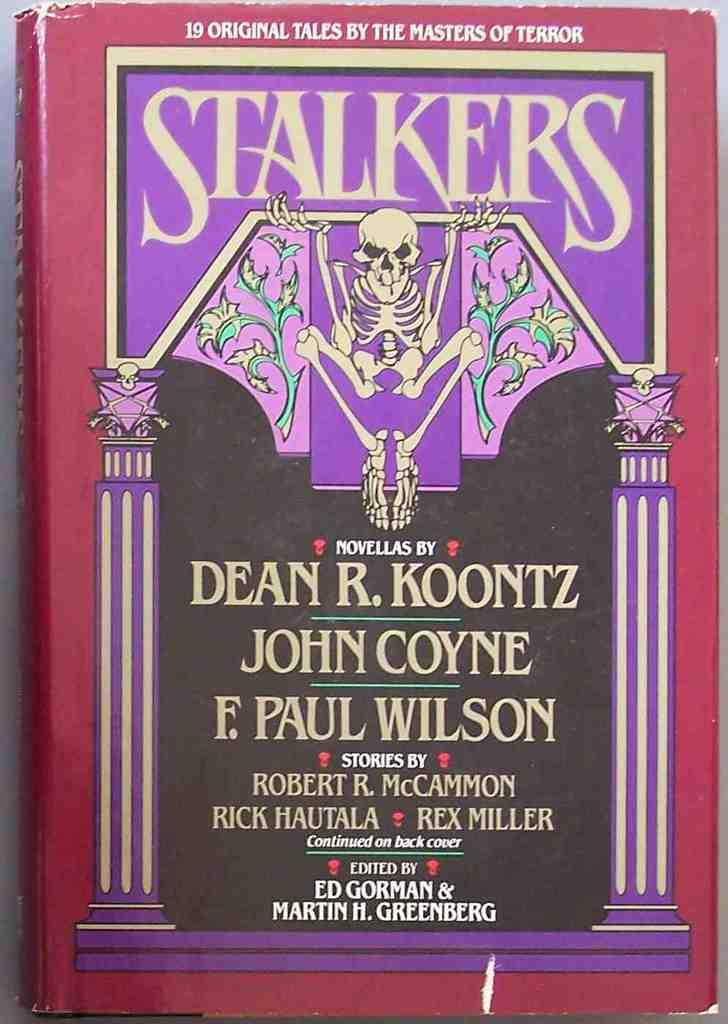Provide a one-sentence caption for the provided image. A book called Stalkers by Robert R. McCammon, Rick Hautala and Rex Miller. 